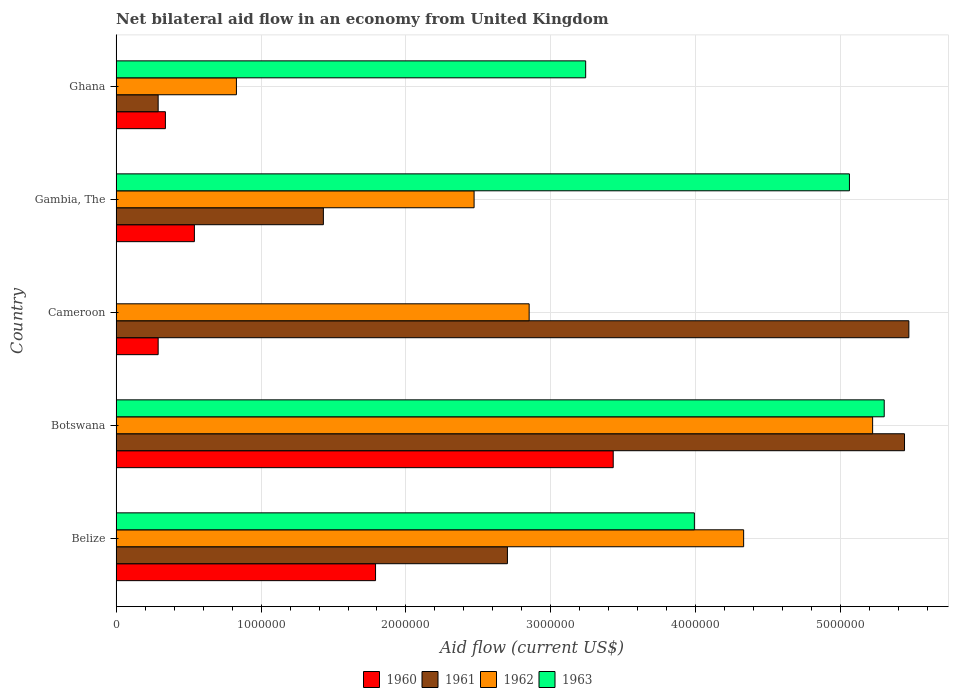Are the number of bars per tick equal to the number of legend labels?
Make the answer very short. No. How many bars are there on the 3rd tick from the top?
Your answer should be very brief. 3. How many bars are there on the 5th tick from the bottom?
Make the answer very short. 4. In how many cases, is the number of bars for a given country not equal to the number of legend labels?
Give a very brief answer. 1. Across all countries, what is the maximum net bilateral aid flow in 1963?
Offer a terse response. 5.30e+06. In which country was the net bilateral aid flow in 1960 maximum?
Ensure brevity in your answer.  Botswana. What is the total net bilateral aid flow in 1961 in the graph?
Your answer should be compact. 1.53e+07. What is the difference between the net bilateral aid flow in 1963 in Ghana and the net bilateral aid flow in 1961 in Cameroon?
Provide a succinct answer. -2.23e+06. What is the average net bilateral aid flow in 1960 per country?
Your response must be concise. 1.28e+06. What is the difference between the net bilateral aid flow in 1963 and net bilateral aid flow in 1961 in Belize?
Give a very brief answer. 1.29e+06. What is the ratio of the net bilateral aid flow in 1960 in Belize to that in Ghana?
Provide a short and direct response. 5.26. What is the difference between the highest and the second highest net bilateral aid flow in 1962?
Keep it short and to the point. 8.90e+05. What is the difference between the highest and the lowest net bilateral aid flow in 1961?
Ensure brevity in your answer.  5.18e+06. In how many countries, is the net bilateral aid flow in 1960 greater than the average net bilateral aid flow in 1960 taken over all countries?
Offer a terse response. 2. Is it the case that in every country, the sum of the net bilateral aid flow in 1963 and net bilateral aid flow in 1961 is greater than the sum of net bilateral aid flow in 1960 and net bilateral aid flow in 1962?
Provide a succinct answer. No. Is it the case that in every country, the sum of the net bilateral aid flow in 1963 and net bilateral aid flow in 1961 is greater than the net bilateral aid flow in 1960?
Your response must be concise. Yes. How many countries are there in the graph?
Your response must be concise. 5. Are the values on the major ticks of X-axis written in scientific E-notation?
Give a very brief answer. No. Where does the legend appear in the graph?
Ensure brevity in your answer.  Bottom center. How many legend labels are there?
Offer a very short reply. 4. How are the legend labels stacked?
Offer a terse response. Horizontal. What is the title of the graph?
Provide a short and direct response. Net bilateral aid flow in an economy from United Kingdom. What is the label or title of the X-axis?
Provide a succinct answer. Aid flow (current US$). What is the label or title of the Y-axis?
Make the answer very short. Country. What is the Aid flow (current US$) of 1960 in Belize?
Your response must be concise. 1.79e+06. What is the Aid flow (current US$) in 1961 in Belize?
Make the answer very short. 2.70e+06. What is the Aid flow (current US$) of 1962 in Belize?
Your answer should be very brief. 4.33e+06. What is the Aid flow (current US$) in 1963 in Belize?
Provide a short and direct response. 3.99e+06. What is the Aid flow (current US$) in 1960 in Botswana?
Provide a succinct answer. 3.43e+06. What is the Aid flow (current US$) in 1961 in Botswana?
Ensure brevity in your answer.  5.44e+06. What is the Aid flow (current US$) of 1962 in Botswana?
Keep it short and to the point. 5.22e+06. What is the Aid flow (current US$) in 1963 in Botswana?
Make the answer very short. 5.30e+06. What is the Aid flow (current US$) in 1960 in Cameroon?
Make the answer very short. 2.90e+05. What is the Aid flow (current US$) in 1961 in Cameroon?
Ensure brevity in your answer.  5.47e+06. What is the Aid flow (current US$) of 1962 in Cameroon?
Your answer should be very brief. 2.85e+06. What is the Aid flow (current US$) in 1963 in Cameroon?
Your response must be concise. 0. What is the Aid flow (current US$) in 1960 in Gambia, The?
Your answer should be compact. 5.40e+05. What is the Aid flow (current US$) in 1961 in Gambia, The?
Provide a short and direct response. 1.43e+06. What is the Aid flow (current US$) of 1962 in Gambia, The?
Ensure brevity in your answer.  2.47e+06. What is the Aid flow (current US$) in 1963 in Gambia, The?
Provide a succinct answer. 5.06e+06. What is the Aid flow (current US$) in 1960 in Ghana?
Ensure brevity in your answer.  3.40e+05. What is the Aid flow (current US$) of 1962 in Ghana?
Your response must be concise. 8.30e+05. What is the Aid flow (current US$) of 1963 in Ghana?
Your answer should be very brief. 3.24e+06. Across all countries, what is the maximum Aid flow (current US$) in 1960?
Ensure brevity in your answer.  3.43e+06. Across all countries, what is the maximum Aid flow (current US$) in 1961?
Offer a very short reply. 5.47e+06. Across all countries, what is the maximum Aid flow (current US$) of 1962?
Your answer should be very brief. 5.22e+06. Across all countries, what is the maximum Aid flow (current US$) in 1963?
Your response must be concise. 5.30e+06. Across all countries, what is the minimum Aid flow (current US$) of 1960?
Your answer should be compact. 2.90e+05. Across all countries, what is the minimum Aid flow (current US$) in 1961?
Your answer should be very brief. 2.90e+05. Across all countries, what is the minimum Aid flow (current US$) in 1962?
Your answer should be very brief. 8.30e+05. Across all countries, what is the minimum Aid flow (current US$) of 1963?
Make the answer very short. 0. What is the total Aid flow (current US$) of 1960 in the graph?
Give a very brief answer. 6.39e+06. What is the total Aid flow (current US$) in 1961 in the graph?
Your answer should be compact. 1.53e+07. What is the total Aid flow (current US$) of 1962 in the graph?
Provide a succinct answer. 1.57e+07. What is the total Aid flow (current US$) in 1963 in the graph?
Keep it short and to the point. 1.76e+07. What is the difference between the Aid flow (current US$) of 1960 in Belize and that in Botswana?
Offer a terse response. -1.64e+06. What is the difference between the Aid flow (current US$) in 1961 in Belize and that in Botswana?
Keep it short and to the point. -2.74e+06. What is the difference between the Aid flow (current US$) of 1962 in Belize and that in Botswana?
Offer a terse response. -8.90e+05. What is the difference between the Aid flow (current US$) in 1963 in Belize and that in Botswana?
Provide a short and direct response. -1.31e+06. What is the difference between the Aid flow (current US$) in 1960 in Belize and that in Cameroon?
Your answer should be very brief. 1.50e+06. What is the difference between the Aid flow (current US$) of 1961 in Belize and that in Cameroon?
Your answer should be compact. -2.77e+06. What is the difference between the Aid flow (current US$) of 1962 in Belize and that in Cameroon?
Provide a short and direct response. 1.48e+06. What is the difference between the Aid flow (current US$) in 1960 in Belize and that in Gambia, The?
Provide a succinct answer. 1.25e+06. What is the difference between the Aid flow (current US$) of 1961 in Belize and that in Gambia, The?
Offer a terse response. 1.27e+06. What is the difference between the Aid flow (current US$) of 1962 in Belize and that in Gambia, The?
Give a very brief answer. 1.86e+06. What is the difference between the Aid flow (current US$) of 1963 in Belize and that in Gambia, The?
Provide a succinct answer. -1.07e+06. What is the difference between the Aid flow (current US$) in 1960 in Belize and that in Ghana?
Provide a succinct answer. 1.45e+06. What is the difference between the Aid flow (current US$) of 1961 in Belize and that in Ghana?
Your answer should be very brief. 2.41e+06. What is the difference between the Aid flow (current US$) in 1962 in Belize and that in Ghana?
Keep it short and to the point. 3.50e+06. What is the difference between the Aid flow (current US$) of 1963 in Belize and that in Ghana?
Provide a short and direct response. 7.50e+05. What is the difference between the Aid flow (current US$) of 1960 in Botswana and that in Cameroon?
Your answer should be very brief. 3.14e+06. What is the difference between the Aid flow (current US$) of 1962 in Botswana and that in Cameroon?
Provide a short and direct response. 2.37e+06. What is the difference between the Aid flow (current US$) in 1960 in Botswana and that in Gambia, The?
Offer a very short reply. 2.89e+06. What is the difference between the Aid flow (current US$) in 1961 in Botswana and that in Gambia, The?
Provide a succinct answer. 4.01e+06. What is the difference between the Aid flow (current US$) of 1962 in Botswana and that in Gambia, The?
Your answer should be very brief. 2.75e+06. What is the difference between the Aid flow (current US$) of 1963 in Botswana and that in Gambia, The?
Provide a short and direct response. 2.40e+05. What is the difference between the Aid flow (current US$) in 1960 in Botswana and that in Ghana?
Keep it short and to the point. 3.09e+06. What is the difference between the Aid flow (current US$) of 1961 in Botswana and that in Ghana?
Offer a very short reply. 5.15e+06. What is the difference between the Aid flow (current US$) of 1962 in Botswana and that in Ghana?
Your response must be concise. 4.39e+06. What is the difference between the Aid flow (current US$) of 1963 in Botswana and that in Ghana?
Provide a short and direct response. 2.06e+06. What is the difference between the Aid flow (current US$) in 1960 in Cameroon and that in Gambia, The?
Keep it short and to the point. -2.50e+05. What is the difference between the Aid flow (current US$) of 1961 in Cameroon and that in Gambia, The?
Keep it short and to the point. 4.04e+06. What is the difference between the Aid flow (current US$) of 1962 in Cameroon and that in Gambia, The?
Give a very brief answer. 3.80e+05. What is the difference between the Aid flow (current US$) in 1960 in Cameroon and that in Ghana?
Your response must be concise. -5.00e+04. What is the difference between the Aid flow (current US$) in 1961 in Cameroon and that in Ghana?
Give a very brief answer. 5.18e+06. What is the difference between the Aid flow (current US$) of 1962 in Cameroon and that in Ghana?
Give a very brief answer. 2.02e+06. What is the difference between the Aid flow (current US$) of 1961 in Gambia, The and that in Ghana?
Keep it short and to the point. 1.14e+06. What is the difference between the Aid flow (current US$) in 1962 in Gambia, The and that in Ghana?
Ensure brevity in your answer.  1.64e+06. What is the difference between the Aid flow (current US$) in 1963 in Gambia, The and that in Ghana?
Ensure brevity in your answer.  1.82e+06. What is the difference between the Aid flow (current US$) of 1960 in Belize and the Aid flow (current US$) of 1961 in Botswana?
Offer a terse response. -3.65e+06. What is the difference between the Aid flow (current US$) of 1960 in Belize and the Aid flow (current US$) of 1962 in Botswana?
Your answer should be compact. -3.43e+06. What is the difference between the Aid flow (current US$) in 1960 in Belize and the Aid flow (current US$) in 1963 in Botswana?
Make the answer very short. -3.51e+06. What is the difference between the Aid flow (current US$) of 1961 in Belize and the Aid flow (current US$) of 1962 in Botswana?
Make the answer very short. -2.52e+06. What is the difference between the Aid flow (current US$) in 1961 in Belize and the Aid flow (current US$) in 1963 in Botswana?
Offer a terse response. -2.60e+06. What is the difference between the Aid flow (current US$) in 1962 in Belize and the Aid flow (current US$) in 1963 in Botswana?
Give a very brief answer. -9.70e+05. What is the difference between the Aid flow (current US$) of 1960 in Belize and the Aid flow (current US$) of 1961 in Cameroon?
Offer a very short reply. -3.68e+06. What is the difference between the Aid flow (current US$) in 1960 in Belize and the Aid flow (current US$) in 1962 in Cameroon?
Ensure brevity in your answer.  -1.06e+06. What is the difference between the Aid flow (current US$) in 1961 in Belize and the Aid flow (current US$) in 1962 in Cameroon?
Your answer should be compact. -1.50e+05. What is the difference between the Aid flow (current US$) in 1960 in Belize and the Aid flow (current US$) in 1962 in Gambia, The?
Your answer should be compact. -6.80e+05. What is the difference between the Aid flow (current US$) of 1960 in Belize and the Aid flow (current US$) of 1963 in Gambia, The?
Offer a terse response. -3.27e+06. What is the difference between the Aid flow (current US$) in 1961 in Belize and the Aid flow (current US$) in 1963 in Gambia, The?
Offer a very short reply. -2.36e+06. What is the difference between the Aid flow (current US$) of 1962 in Belize and the Aid flow (current US$) of 1963 in Gambia, The?
Keep it short and to the point. -7.30e+05. What is the difference between the Aid flow (current US$) in 1960 in Belize and the Aid flow (current US$) in 1961 in Ghana?
Make the answer very short. 1.50e+06. What is the difference between the Aid flow (current US$) in 1960 in Belize and the Aid flow (current US$) in 1962 in Ghana?
Your answer should be compact. 9.60e+05. What is the difference between the Aid flow (current US$) of 1960 in Belize and the Aid flow (current US$) of 1963 in Ghana?
Keep it short and to the point. -1.45e+06. What is the difference between the Aid flow (current US$) of 1961 in Belize and the Aid flow (current US$) of 1962 in Ghana?
Offer a terse response. 1.87e+06. What is the difference between the Aid flow (current US$) in 1961 in Belize and the Aid flow (current US$) in 1963 in Ghana?
Make the answer very short. -5.40e+05. What is the difference between the Aid flow (current US$) in 1962 in Belize and the Aid flow (current US$) in 1963 in Ghana?
Make the answer very short. 1.09e+06. What is the difference between the Aid flow (current US$) of 1960 in Botswana and the Aid flow (current US$) of 1961 in Cameroon?
Give a very brief answer. -2.04e+06. What is the difference between the Aid flow (current US$) of 1960 in Botswana and the Aid flow (current US$) of 1962 in Cameroon?
Give a very brief answer. 5.80e+05. What is the difference between the Aid flow (current US$) of 1961 in Botswana and the Aid flow (current US$) of 1962 in Cameroon?
Offer a terse response. 2.59e+06. What is the difference between the Aid flow (current US$) in 1960 in Botswana and the Aid flow (current US$) in 1961 in Gambia, The?
Provide a succinct answer. 2.00e+06. What is the difference between the Aid flow (current US$) of 1960 in Botswana and the Aid flow (current US$) of 1962 in Gambia, The?
Your answer should be compact. 9.60e+05. What is the difference between the Aid flow (current US$) in 1960 in Botswana and the Aid flow (current US$) in 1963 in Gambia, The?
Your answer should be compact. -1.63e+06. What is the difference between the Aid flow (current US$) of 1961 in Botswana and the Aid flow (current US$) of 1962 in Gambia, The?
Keep it short and to the point. 2.97e+06. What is the difference between the Aid flow (current US$) in 1960 in Botswana and the Aid flow (current US$) in 1961 in Ghana?
Make the answer very short. 3.14e+06. What is the difference between the Aid flow (current US$) of 1960 in Botswana and the Aid flow (current US$) of 1962 in Ghana?
Make the answer very short. 2.60e+06. What is the difference between the Aid flow (current US$) of 1961 in Botswana and the Aid flow (current US$) of 1962 in Ghana?
Give a very brief answer. 4.61e+06. What is the difference between the Aid flow (current US$) of 1961 in Botswana and the Aid flow (current US$) of 1963 in Ghana?
Your answer should be very brief. 2.20e+06. What is the difference between the Aid flow (current US$) in 1962 in Botswana and the Aid flow (current US$) in 1963 in Ghana?
Provide a succinct answer. 1.98e+06. What is the difference between the Aid flow (current US$) of 1960 in Cameroon and the Aid flow (current US$) of 1961 in Gambia, The?
Make the answer very short. -1.14e+06. What is the difference between the Aid flow (current US$) of 1960 in Cameroon and the Aid flow (current US$) of 1962 in Gambia, The?
Ensure brevity in your answer.  -2.18e+06. What is the difference between the Aid flow (current US$) of 1960 in Cameroon and the Aid flow (current US$) of 1963 in Gambia, The?
Provide a short and direct response. -4.77e+06. What is the difference between the Aid flow (current US$) of 1962 in Cameroon and the Aid flow (current US$) of 1963 in Gambia, The?
Provide a short and direct response. -2.21e+06. What is the difference between the Aid flow (current US$) of 1960 in Cameroon and the Aid flow (current US$) of 1961 in Ghana?
Provide a short and direct response. 0. What is the difference between the Aid flow (current US$) in 1960 in Cameroon and the Aid flow (current US$) in 1962 in Ghana?
Your response must be concise. -5.40e+05. What is the difference between the Aid flow (current US$) of 1960 in Cameroon and the Aid flow (current US$) of 1963 in Ghana?
Make the answer very short. -2.95e+06. What is the difference between the Aid flow (current US$) of 1961 in Cameroon and the Aid flow (current US$) of 1962 in Ghana?
Provide a succinct answer. 4.64e+06. What is the difference between the Aid flow (current US$) in 1961 in Cameroon and the Aid flow (current US$) in 1963 in Ghana?
Make the answer very short. 2.23e+06. What is the difference between the Aid flow (current US$) of 1962 in Cameroon and the Aid flow (current US$) of 1963 in Ghana?
Your answer should be very brief. -3.90e+05. What is the difference between the Aid flow (current US$) in 1960 in Gambia, The and the Aid flow (current US$) in 1963 in Ghana?
Give a very brief answer. -2.70e+06. What is the difference between the Aid flow (current US$) of 1961 in Gambia, The and the Aid flow (current US$) of 1962 in Ghana?
Your answer should be very brief. 6.00e+05. What is the difference between the Aid flow (current US$) in 1961 in Gambia, The and the Aid flow (current US$) in 1963 in Ghana?
Your answer should be compact. -1.81e+06. What is the difference between the Aid flow (current US$) in 1962 in Gambia, The and the Aid flow (current US$) in 1963 in Ghana?
Offer a very short reply. -7.70e+05. What is the average Aid flow (current US$) in 1960 per country?
Offer a terse response. 1.28e+06. What is the average Aid flow (current US$) in 1961 per country?
Offer a very short reply. 3.07e+06. What is the average Aid flow (current US$) of 1962 per country?
Keep it short and to the point. 3.14e+06. What is the average Aid flow (current US$) of 1963 per country?
Your response must be concise. 3.52e+06. What is the difference between the Aid flow (current US$) in 1960 and Aid flow (current US$) in 1961 in Belize?
Your answer should be very brief. -9.10e+05. What is the difference between the Aid flow (current US$) of 1960 and Aid flow (current US$) of 1962 in Belize?
Your response must be concise. -2.54e+06. What is the difference between the Aid flow (current US$) in 1960 and Aid flow (current US$) in 1963 in Belize?
Offer a very short reply. -2.20e+06. What is the difference between the Aid flow (current US$) in 1961 and Aid flow (current US$) in 1962 in Belize?
Offer a terse response. -1.63e+06. What is the difference between the Aid flow (current US$) in 1961 and Aid flow (current US$) in 1963 in Belize?
Offer a very short reply. -1.29e+06. What is the difference between the Aid flow (current US$) of 1960 and Aid flow (current US$) of 1961 in Botswana?
Provide a short and direct response. -2.01e+06. What is the difference between the Aid flow (current US$) of 1960 and Aid flow (current US$) of 1962 in Botswana?
Ensure brevity in your answer.  -1.79e+06. What is the difference between the Aid flow (current US$) of 1960 and Aid flow (current US$) of 1963 in Botswana?
Your response must be concise. -1.87e+06. What is the difference between the Aid flow (current US$) in 1960 and Aid flow (current US$) in 1961 in Cameroon?
Provide a succinct answer. -5.18e+06. What is the difference between the Aid flow (current US$) of 1960 and Aid flow (current US$) of 1962 in Cameroon?
Give a very brief answer. -2.56e+06. What is the difference between the Aid flow (current US$) of 1961 and Aid flow (current US$) of 1962 in Cameroon?
Your response must be concise. 2.62e+06. What is the difference between the Aid flow (current US$) in 1960 and Aid flow (current US$) in 1961 in Gambia, The?
Provide a succinct answer. -8.90e+05. What is the difference between the Aid flow (current US$) in 1960 and Aid flow (current US$) in 1962 in Gambia, The?
Make the answer very short. -1.93e+06. What is the difference between the Aid flow (current US$) of 1960 and Aid flow (current US$) of 1963 in Gambia, The?
Your answer should be compact. -4.52e+06. What is the difference between the Aid flow (current US$) of 1961 and Aid flow (current US$) of 1962 in Gambia, The?
Your answer should be compact. -1.04e+06. What is the difference between the Aid flow (current US$) of 1961 and Aid flow (current US$) of 1963 in Gambia, The?
Make the answer very short. -3.63e+06. What is the difference between the Aid flow (current US$) in 1962 and Aid flow (current US$) in 1963 in Gambia, The?
Give a very brief answer. -2.59e+06. What is the difference between the Aid flow (current US$) of 1960 and Aid flow (current US$) of 1962 in Ghana?
Offer a very short reply. -4.90e+05. What is the difference between the Aid flow (current US$) in 1960 and Aid flow (current US$) in 1963 in Ghana?
Offer a very short reply. -2.90e+06. What is the difference between the Aid flow (current US$) in 1961 and Aid flow (current US$) in 1962 in Ghana?
Keep it short and to the point. -5.40e+05. What is the difference between the Aid flow (current US$) in 1961 and Aid flow (current US$) in 1963 in Ghana?
Keep it short and to the point. -2.95e+06. What is the difference between the Aid flow (current US$) in 1962 and Aid flow (current US$) in 1963 in Ghana?
Keep it short and to the point. -2.41e+06. What is the ratio of the Aid flow (current US$) of 1960 in Belize to that in Botswana?
Offer a terse response. 0.52. What is the ratio of the Aid flow (current US$) in 1961 in Belize to that in Botswana?
Offer a very short reply. 0.5. What is the ratio of the Aid flow (current US$) in 1962 in Belize to that in Botswana?
Offer a very short reply. 0.83. What is the ratio of the Aid flow (current US$) of 1963 in Belize to that in Botswana?
Ensure brevity in your answer.  0.75. What is the ratio of the Aid flow (current US$) in 1960 in Belize to that in Cameroon?
Offer a terse response. 6.17. What is the ratio of the Aid flow (current US$) in 1961 in Belize to that in Cameroon?
Your response must be concise. 0.49. What is the ratio of the Aid flow (current US$) in 1962 in Belize to that in Cameroon?
Give a very brief answer. 1.52. What is the ratio of the Aid flow (current US$) of 1960 in Belize to that in Gambia, The?
Keep it short and to the point. 3.31. What is the ratio of the Aid flow (current US$) in 1961 in Belize to that in Gambia, The?
Ensure brevity in your answer.  1.89. What is the ratio of the Aid flow (current US$) of 1962 in Belize to that in Gambia, The?
Ensure brevity in your answer.  1.75. What is the ratio of the Aid flow (current US$) in 1963 in Belize to that in Gambia, The?
Make the answer very short. 0.79. What is the ratio of the Aid flow (current US$) in 1960 in Belize to that in Ghana?
Offer a terse response. 5.26. What is the ratio of the Aid flow (current US$) in 1961 in Belize to that in Ghana?
Your answer should be compact. 9.31. What is the ratio of the Aid flow (current US$) in 1962 in Belize to that in Ghana?
Make the answer very short. 5.22. What is the ratio of the Aid flow (current US$) in 1963 in Belize to that in Ghana?
Ensure brevity in your answer.  1.23. What is the ratio of the Aid flow (current US$) in 1960 in Botswana to that in Cameroon?
Provide a succinct answer. 11.83. What is the ratio of the Aid flow (current US$) of 1961 in Botswana to that in Cameroon?
Make the answer very short. 0.99. What is the ratio of the Aid flow (current US$) in 1962 in Botswana to that in Cameroon?
Make the answer very short. 1.83. What is the ratio of the Aid flow (current US$) in 1960 in Botswana to that in Gambia, The?
Offer a terse response. 6.35. What is the ratio of the Aid flow (current US$) of 1961 in Botswana to that in Gambia, The?
Provide a short and direct response. 3.8. What is the ratio of the Aid flow (current US$) in 1962 in Botswana to that in Gambia, The?
Your response must be concise. 2.11. What is the ratio of the Aid flow (current US$) in 1963 in Botswana to that in Gambia, The?
Ensure brevity in your answer.  1.05. What is the ratio of the Aid flow (current US$) in 1960 in Botswana to that in Ghana?
Your response must be concise. 10.09. What is the ratio of the Aid flow (current US$) of 1961 in Botswana to that in Ghana?
Your response must be concise. 18.76. What is the ratio of the Aid flow (current US$) in 1962 in Botswana to that in Ghana?
Give a very brief answer. 6.29. What is the ratio of the Aid flow (current US$) of 1963 in Botswana to that in Ghana?
Make the answer very short. 1.64. What is the ratio of the Aid flow (current US$) of 1960 in Cameroon to that in Gambia, The?
Give a very brief answer. 0.54. What is the ratio of the Aid flow (current US$) of 1961 in Cameroon to that in Gambia, The?
Provide a succinct answer. 3.83. What is the ratio of the Aid flow (current US$) of 1962 in Cameroon to that in Gambia, The?
Provide a succinct answer. 1.15. What is the ratio of the Aid flow (current US$) in 1960 in Cameroon to that in Ghana?
Make the answer very short. 0.85. What is the ratio of the Aid flow (current US$) of 1961 in Cameroon to that in Ghana?
Offer a very short reply. 18.86. What is the ratio of the Aid flow (current US$) of 1962 in Cameroon to that in Ghana?
Make the answer very short. 3.43. What is the ratio of the Aid flow (current US$) of 1960 in Gambia, The to that in Ghana?
Offer a terse response. 1.59. What is the ratio of the Aid flow (current US$) of 1961 in Gambia, The to that in Ghana?
Your answer should be compact. 4.93. What is the ratio of the Aid flow (current US$) of 1962 in Gambia, The to that in Ghana?
Keep it short and to the point. 2.98. What is the ratio of the Aid flow (current US$) in 1963 in Gambia, The to that in Ghana?
Your answer should be very brief. 1.56. What is the difference between the highest and the second highest Aid flow (current US$) in 1960?
Give a very brief answer. 1.64e+06. What is the difference between the highest and the second highest Aid flow (current US$) of 1962?
Offer a very short reply. 8.90e+05. What is the difference between the highest and the second highest Aid flow (current US$) in 1963?
Keep it short and to the point. 2.40e+05. What is the difference between the highest and the lowest Aid flow (current US$) in 1960?
Provide a short and direct response. 3.14e+06. What is the difference between the highest and the lowest Aid flow (current US$) of 1961?
Offer a terse response. 5.18e+06. What is the difference between the highest and the lowest Aid flow (current US$) of 1962?
Your response must be concise. 4.39e+06. What is the difference between the highest and the lowest Aid flow (current US$) of 1963?
Your response must be concise. 5.30e+06. 